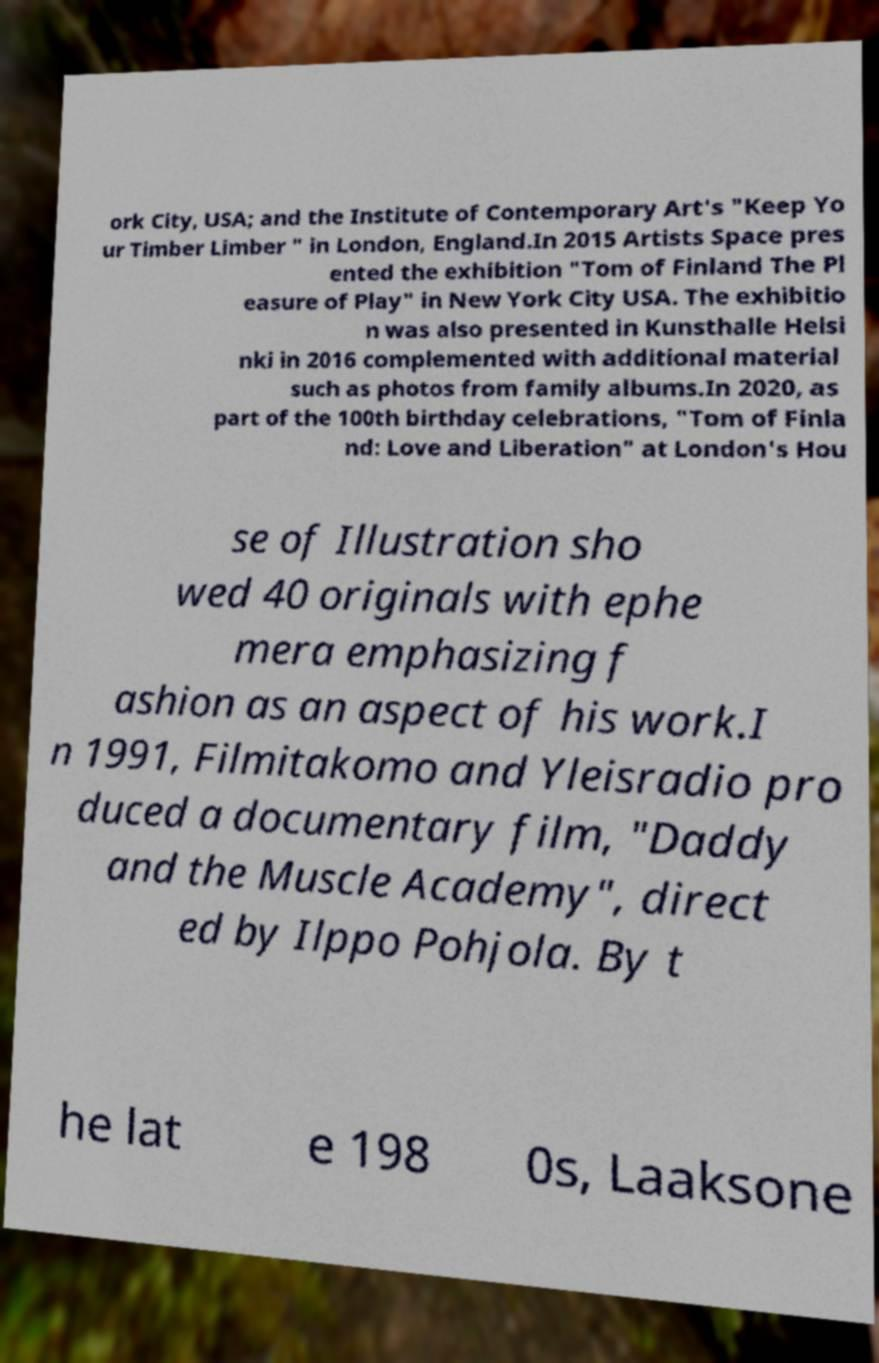What messages or text are displayed in this image? I need them in a readable, typed format. ork City, USA; and the Institute of Contemporary Art's "Keep Yo ur Timber Limber " in London, England.In 2015 Artists Space pres ented the exhibition "Tom of Finland The Pl easure of Play" in New York City USA. The exhibitio n was also presented in Kunsthalle Helsi nki in 2016 complemented with additional material such as photos from family albums.In 2020, as part of the 100th birthday celebrations, "Tom of Finla nd: Love and Liberation" at London's Hou se of Illustration sho wed 40 originals with ephe mera emphasizing f ashion as an aspect of his work.I n 1991, Filmitakomo and Yleisradio pro duced a documentary film, "Daddy and the Muscle Academy", direct ed by Ilppo Pohjola. By t he lat e 198 0s, Laaksone 